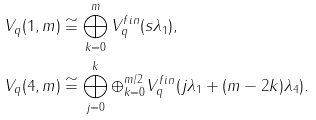Convert formula to latex. <formula><loc_0><loc_0><loc_500><loc_500>V _ { q } ( 1 , m ) & \cong \bigoplus _ { k = 0 } ^ { m } V _ { q } ^ { f i n } ( s \lambda _ { 1 } ) , \\ V _ { q } ( 4 , m ) & \cong \bigoplus _ { j = 0 } ^ { k } \oplus _ { k = 0 } ^ { m / 2 } V _ { q } ^ { f i n } ( j \lambda _ { 1 } + ( m - 2 k ) \lambda _ { 4 } ) .</formula> 